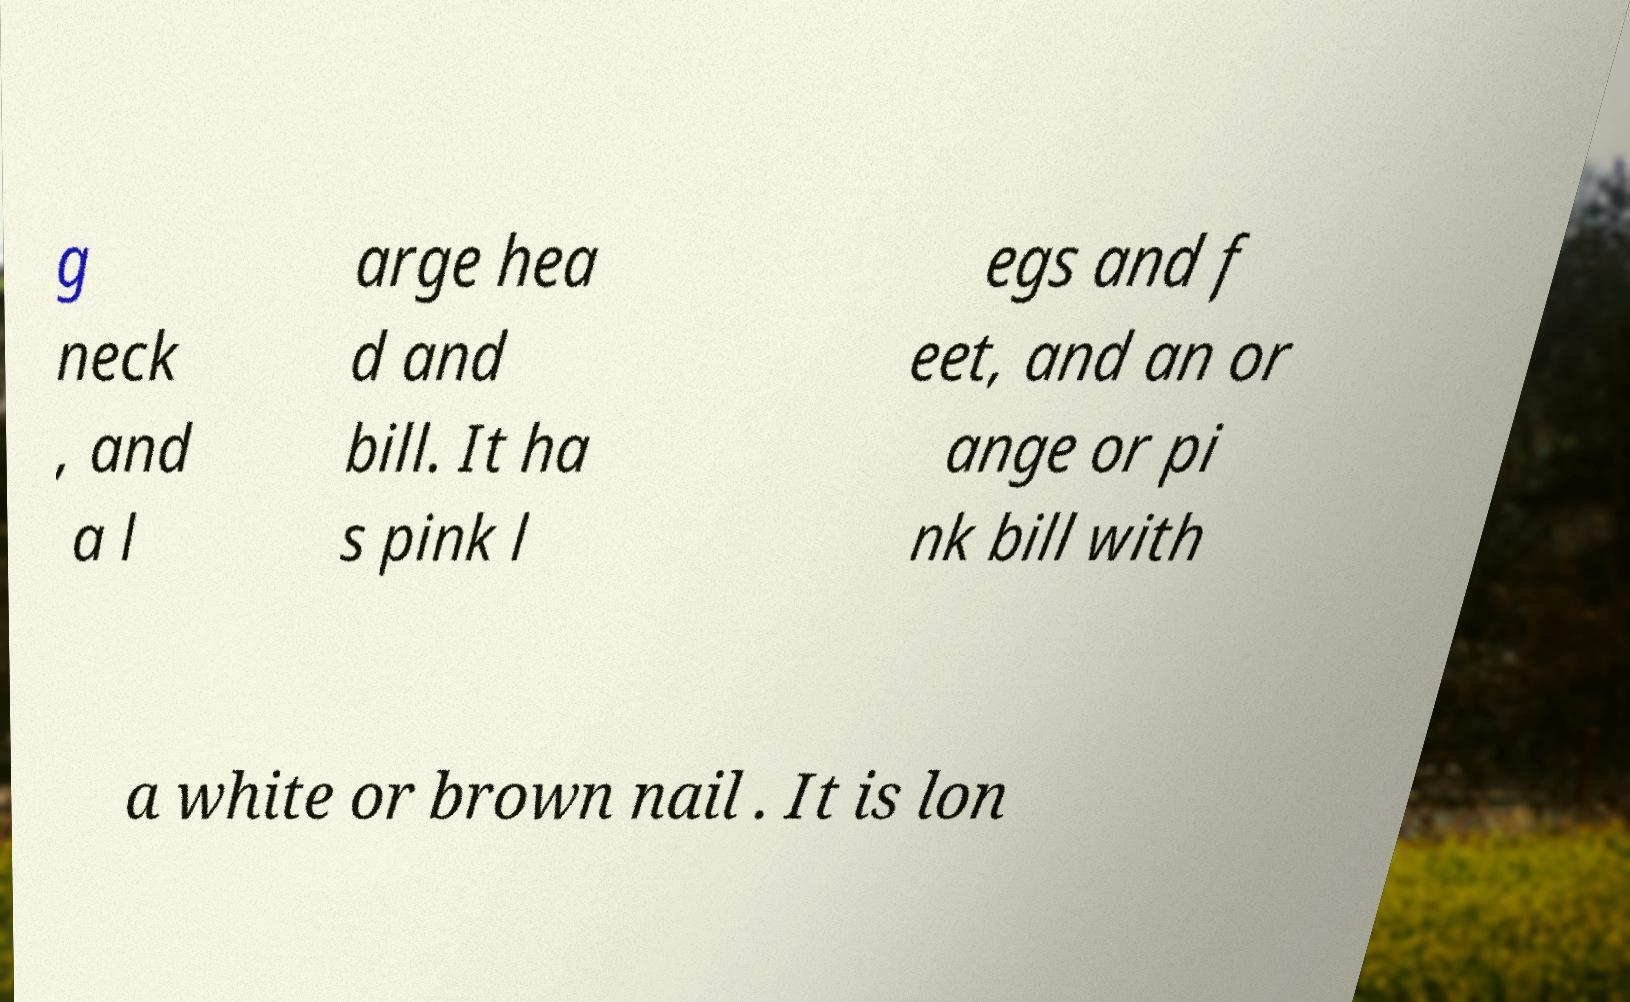For documentation purposes, I need the text within this image transcribed. Could you provide that? g neck , and a l arge hea d and bill. It ha s pink l egs and f eet, and an or ange or pi nk bill with a white or brown nail . It is lon 